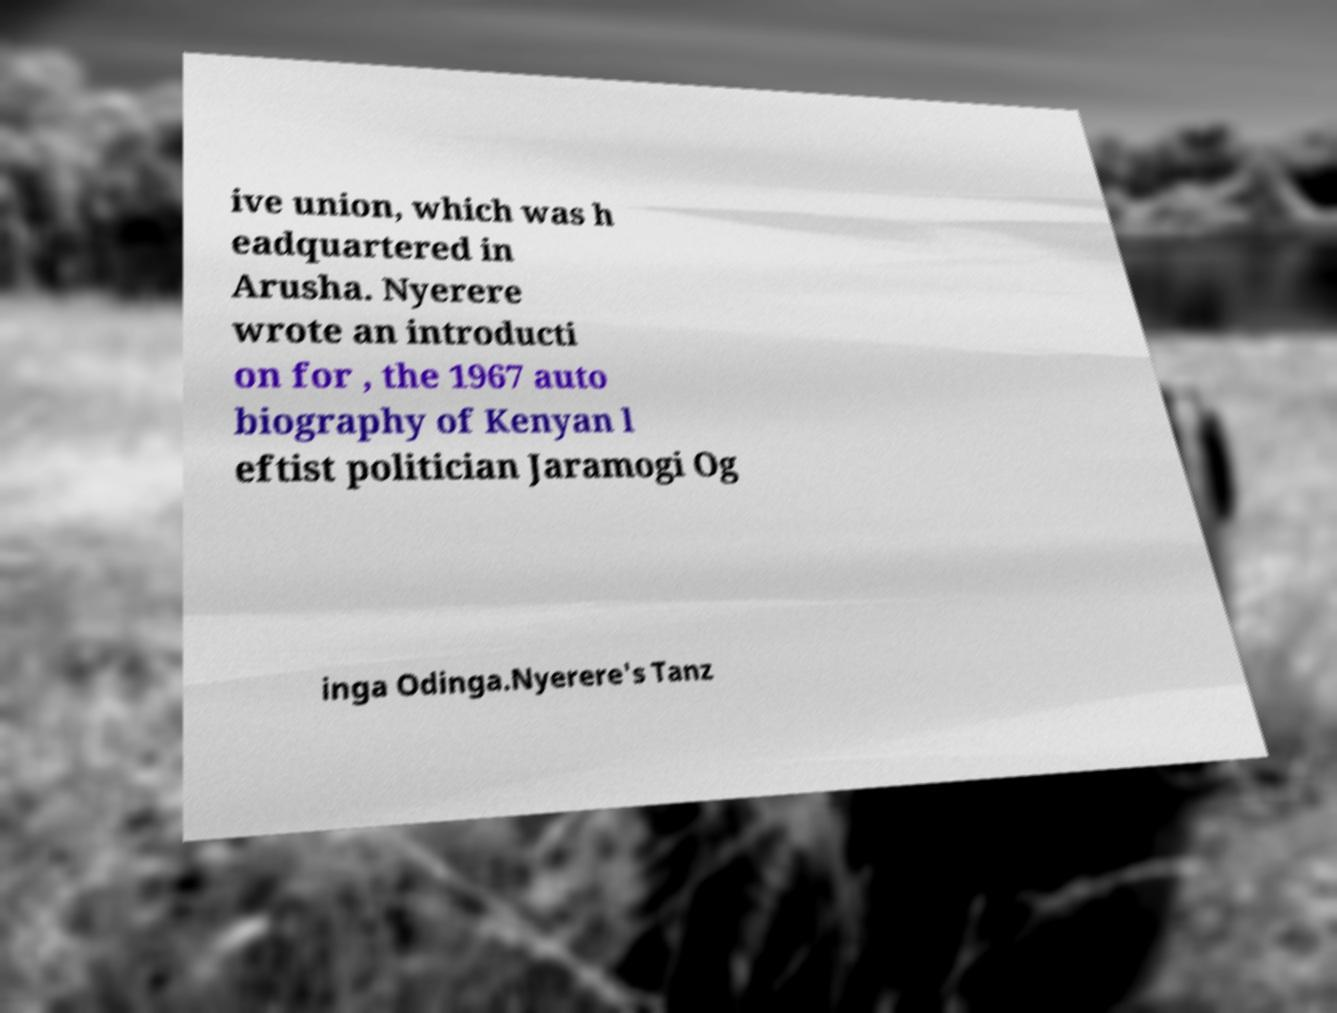For documentation purposes, I need the text within this image transcribed. Could you provide that? ive union, which was h eadquartered in Arusha. Nyerere wrote an introducti on for , the 1967 auto biography of Kenyan l eftist politician Jaramogi Og inga Odinga.Nyerere's Tanz 